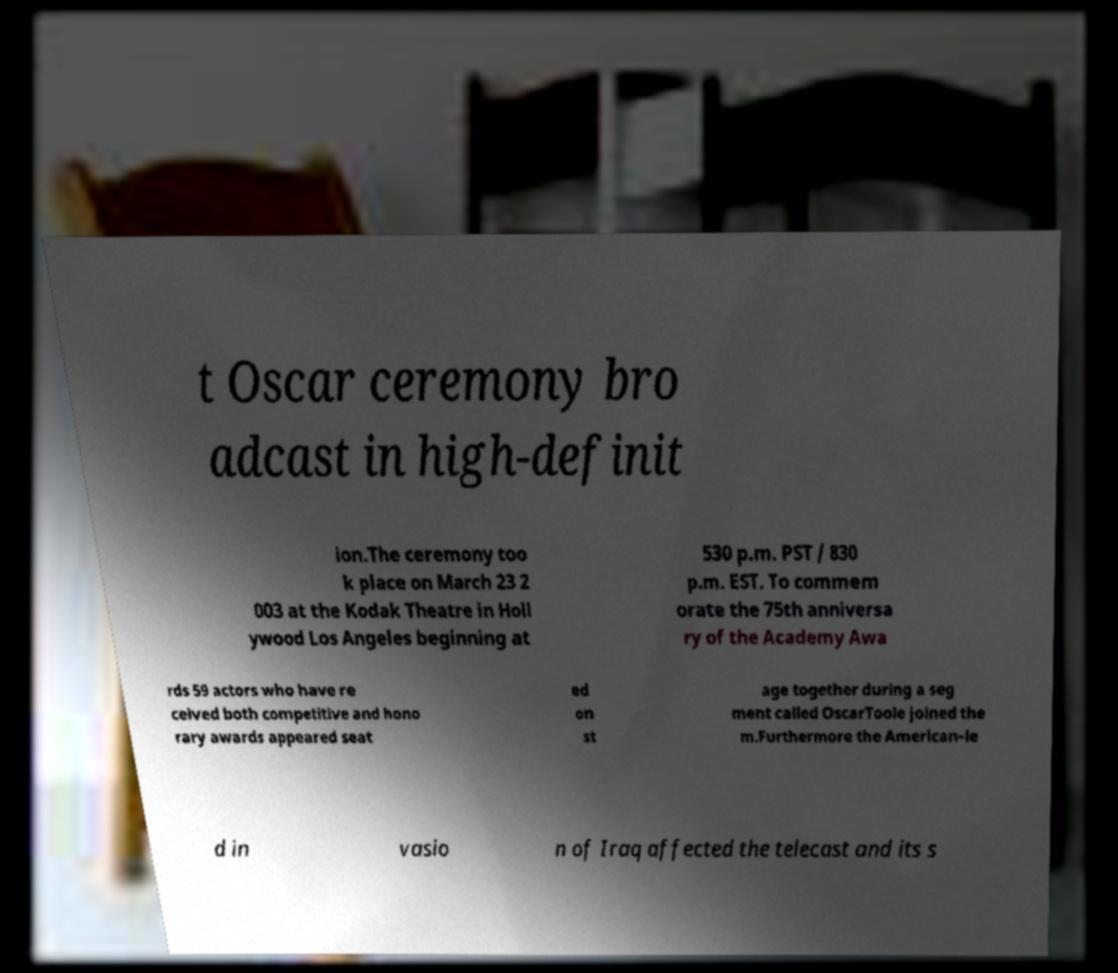Please read and relay the text visible in this image. What does it say? t Oscar ceremony bro adcast in high-definit ion.The ceremony too k place on March 23 2 003 at the Kodak Theatre in Holl ywood Los Angeles beginning at 530 p.m. PST / 830 p.m. EST. To commem orate the 75th anniversa ry of the Academy Awa rds 59 actors who have re ceived both competitive and hono rary awards appeared seat ed on st age together during a seg ment called OscarToole joined the m.Furthermore the American-le d in vasio n of Iraq affected the telecast and its s 